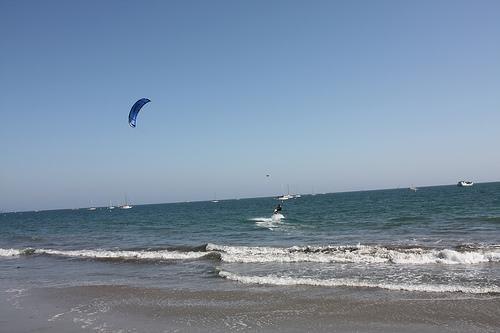How many people can you see?
Give a very brief answer. 1. 